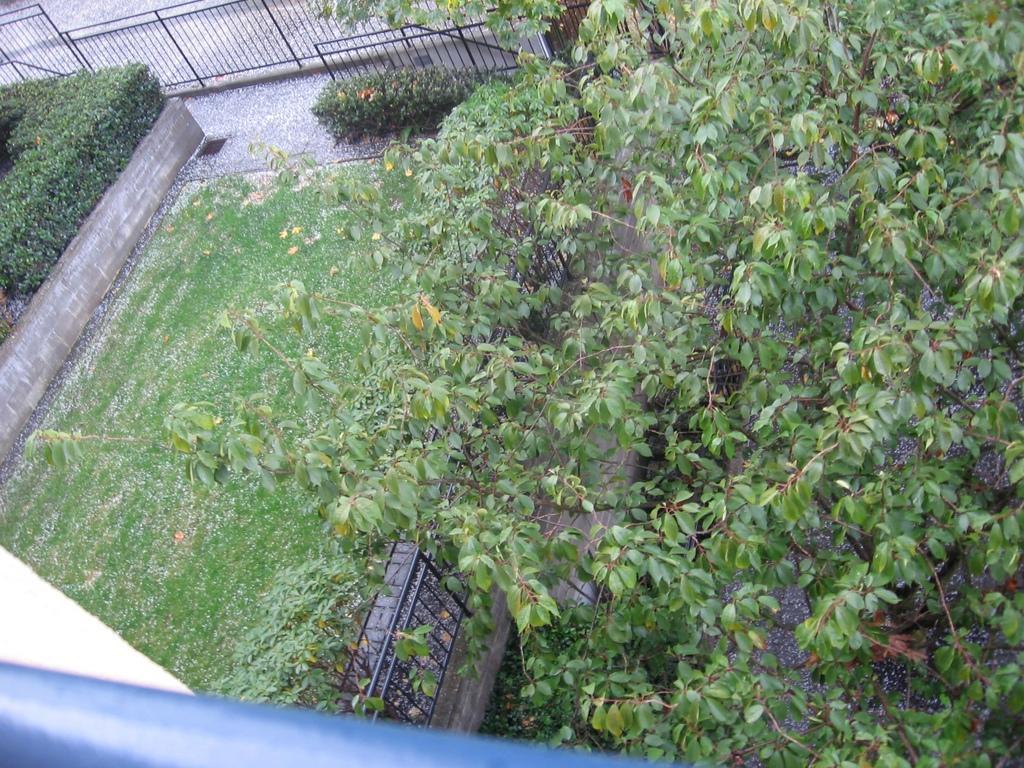How would you summarize this image in a sentence or two? At the bottom of the picture, we see a blue color rod. On the right side, we see the trees. In the middle, we see the iron railing, shrubs and the grass. On the left side, we see the shrubs. At the top, we see the iron railing and the plants. 